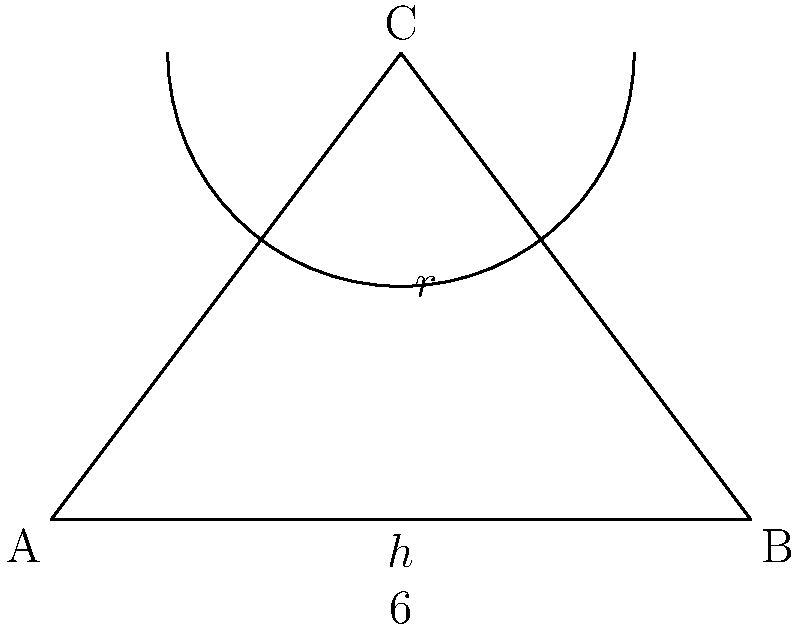A community concert hall is being designed with a triangular stage and a semicircular seating area. The base of the stage is 6 meters wide, and the height of the triangle is $h$ meters. The radius of the semicircular seating area is $r$ meters. If the total area of the stage and seating area must be 40 square meters, find the dimensions that will maximize the number of seats (which is proportional to the circumference of the semicircle). What is the optimal radius $r$ to the nearest tenth of a meter? Let's approach this step-by-step:

1) The area of the triangular stage is: $A_t = \frac{1}{2} \cdot 6 \cdot h = 3h$

2) The area of the semicircular seating is: $A_s = \frac{1}{2} \pi r^2$

3) The total area is given as 40 square meters, so:
   $3h + \frac{1}{2} \pi r^2 = 40$

4) From the diagram, we can see that $h + r = 4$ (the height of the triangle plus the radius equals the height of the whole figure). So $h = 4 - r$

5) Substituting this into our area equation:
   $3(4-r) + \frac{1}{2} \pi r^2 = 40$
   $12 - 3r + \frac{1}{2} \pi r^2 = 40$
   $\frac{1}{2} \pi r^2 - 3r - 28 = 0$

6) The circumference of the semicircle (proportional to the number of seats) is $\pi r$. We want to maximize this.

7) To find the maximum, we differentiate $\pi r$ with respect to $r$ and set it to zero:
   $\frac{d}{dr}(\pi r) = \pi$

   This is always positive, meaning $\pi r$ increases as $r$ increases. So we want the largest possible $r$.

8) The largest possible $r$ will occur when the quadratic equation in step 5 has only one solution (at the vertex of the parabola).

9) For a quadratic $ax^2 + bx + c = 0$, this occurs when $b^2 - 4ac = 0$

10) In our case, $a = \frac{1}{2} \pi$, $b = -3$, and $c = -28$

11) Solving $(-3)^2 - 4(\frac{1}{2} \pi)(-28) = 0$:
    $9 + 56\pi = 0$
    $56\pi = -9$
    $\pi = -\frac{9}{56}$

12) This is impossible since $\pi$ is positive. Therefore, the maximum must occur at the largest root of the quadratic equation.

13) Using the quadratic formula:
    $r = \frac{3 \pm \sqrt{9 + 56\pi}}{2(\frac{1}{2} \pi)} = \frac{3 \pm \sqrt{9 + 56\pi}}{\pi}$

14) We want the larger root, so we use the + sign:
    $r = \frac{3 + \sqrt{9 + 56\pi}}{\pi} \approx 3.6$ meters
Answer: 3.6 meters 